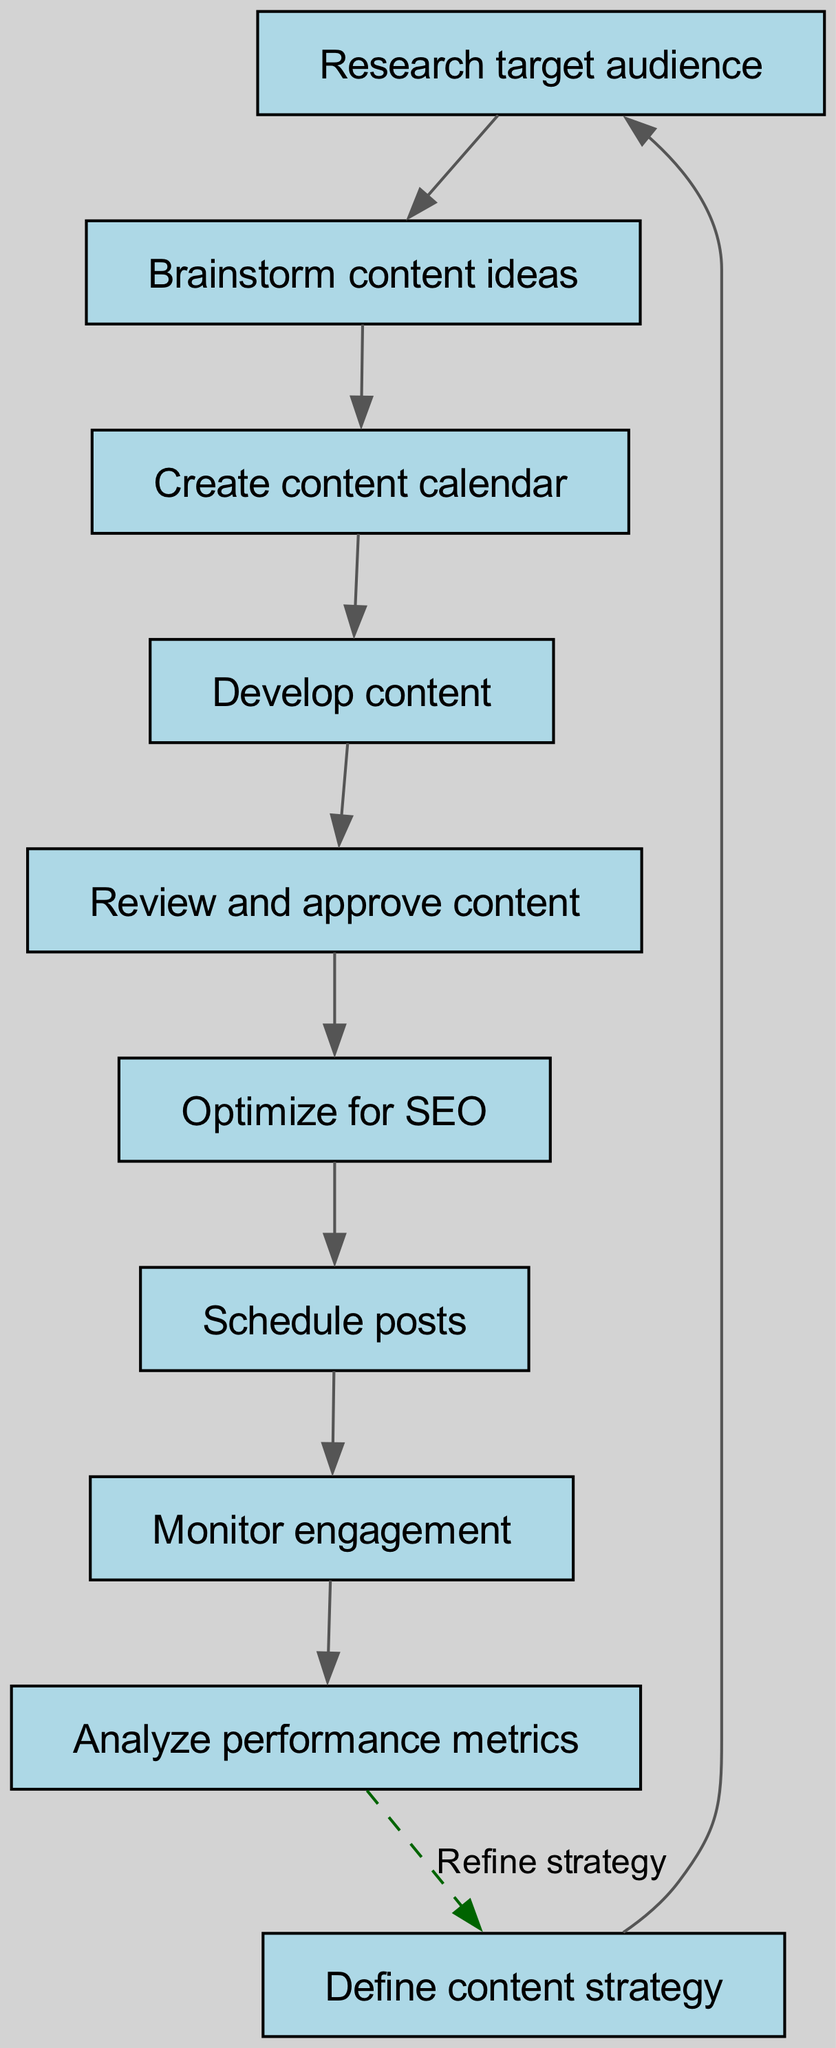What is the starting node in the workflow? The starting node, labeled as "Define content strategy", is the first step in the workflow from which all other nodes branch out. It serves as the foundation of the entire process.
Answer: Define content strategy How many nodes are there in the diagram? Counting all distinct steps or elements in the diagram, we include the initial node and all subsequent nodes. There are a total of 10 nodes present in the workflow.
Answer: 10 Which node comes after "Optimize for SEO"? By following the arrows in the diagram that indicate the flow from one node to another, it's clear that the next step after "Optimize for SEO" is "Schedule posts".
Answer: Schedule posts What is the relationship between "Review and approve content" and "Develop content"? The relationship is sequential; after "Develop content" is completed, the next step is to "Review and approve content", indicating a step that depends on the prior completion.
Answer: Sequential What happens after "Analyze performance metrics"? The flow from "Analyze performance metrics" leads back to "Define content strategy", showing that this step is a feedback loop that implicates revisiting the initial strategy based on the analysis.
Answer: Refine strategy How many edges connect the nodes in the diagram? Each connection or directional line between two nodes represents an edge, and by counting these connections, we find there are a total of 9 edges in the workflow.
Answer: 9 What step follows immediately after "Monitor engagement"? Following the flow, the step that comes immediately after "Monitor engagement" is "Analyze performance metrics", which signifies data evaluation after observing audience interaction.
Answer: Analyze performance metrics How does the workflow begin? The workflow begins with the action of defining a content strategy, indicating the primary focus for the content creation process before executing any other steps.
Answer: Define content strategy What is the purpose of looping back to "Define content strategy"? The loop back to "Define content strategy" suggests a process of continually refining and improving the content strategy based on performance metrics obtained from previous actions in the workflow.
Answer: Refine strategy 